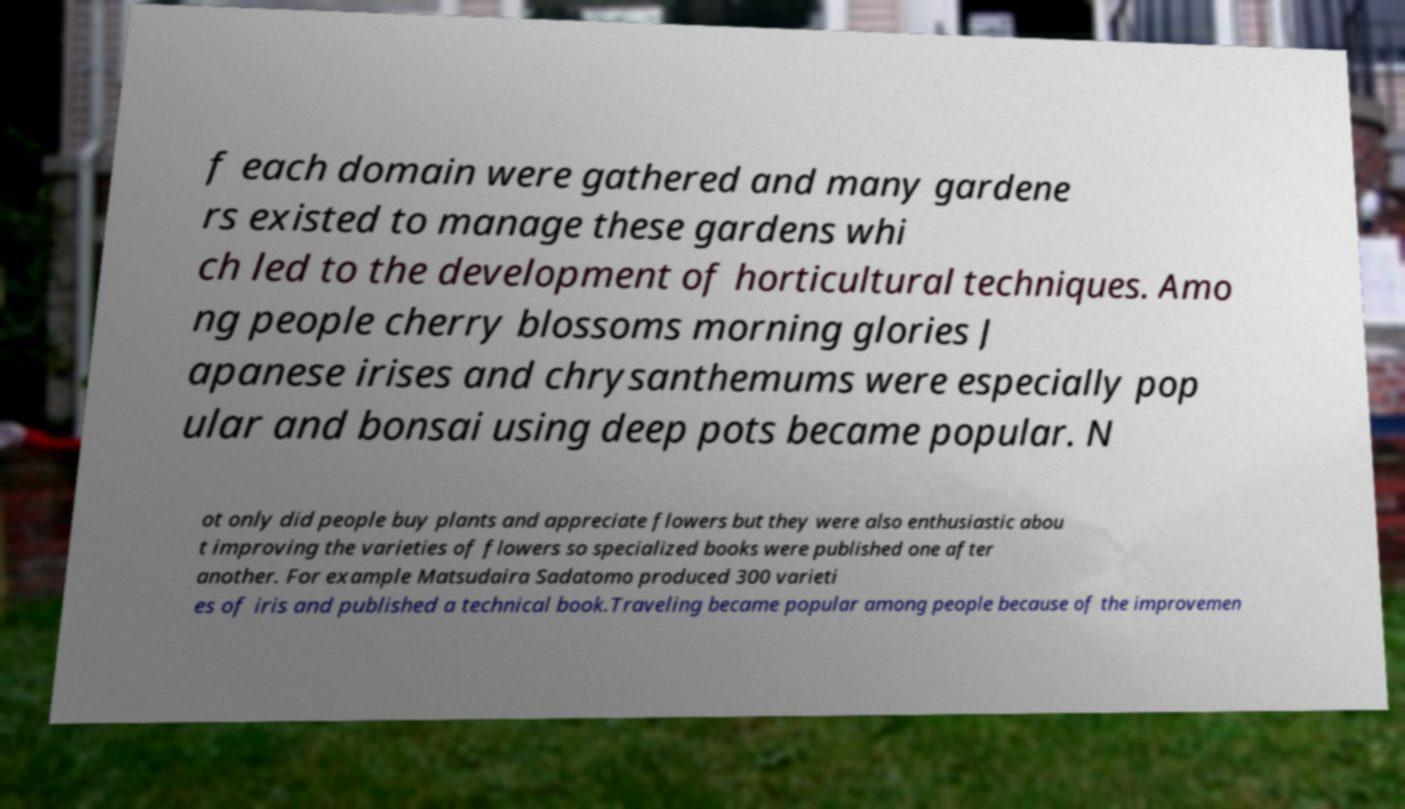Could you extract and type out the text from this image? f each domain were gathered and many gardene rs existed to manage these gardens whi ch led to the development of horticultural techniques. Amo ng people cherry blossoms morning glories J apanese irises and chrysanthemums were especially pop ular and bonsai using deep pots became popular. N ot only did people buy plants and appreciate flowers but they were also enthusiastic abou t improving the varieties of flowers so specialized books were published one after another. For example Matsudaira Sadatomo produced 300 varieti es of iris and published a technical book.Traveling became popular among people because of the improvemen 